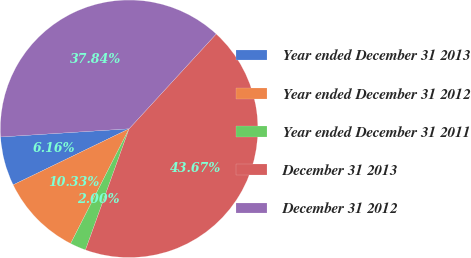Convert chart to OTSL. <chart><loc_0><loc_0><loc_500><loc_500><pie_chart><fcel>Year ended December 31 2013<fcel>Year ended December 31 2012<fcel>Year ended December 31 2011<fcel>December 31 2013<fcel>December 31 2012<nl><fcel>6.16%<fcel>10.33%<fcel>2.0%<fcel>43.67%<fcel>37.84%<nl></chart> 